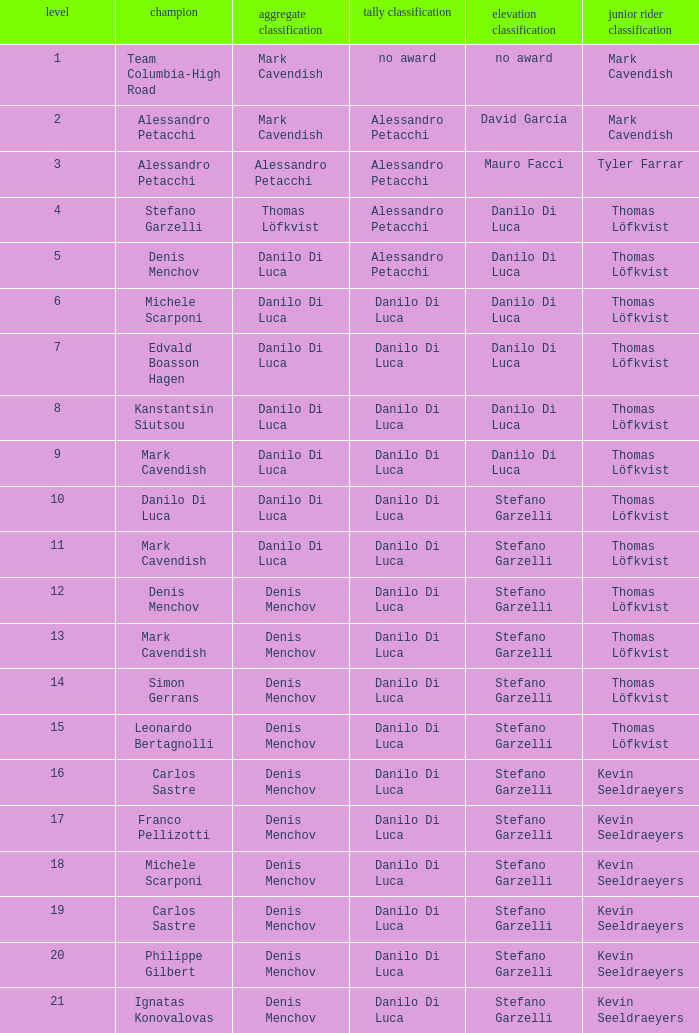When philippe gilbert is the winner who is the points classification? Danilo Di Luca. 